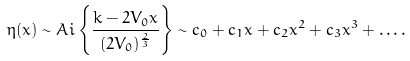Convert formula to latex. <formula><loc_0><loc_0><loc_500><loc_500>\eta ( x ) \sim A i \left \{ \frac { k - 2 V _ { 0 } x } { ( 2 V _ { 0 } ) ^ { \frac { 2 } { 3 } } } \right \} \sim c _ { 0 } + c _ { 1 } x + c _ { 2 } x ^ { 2 } + c _ { 3 } x ^ { 3 } + \dots .</formula> 